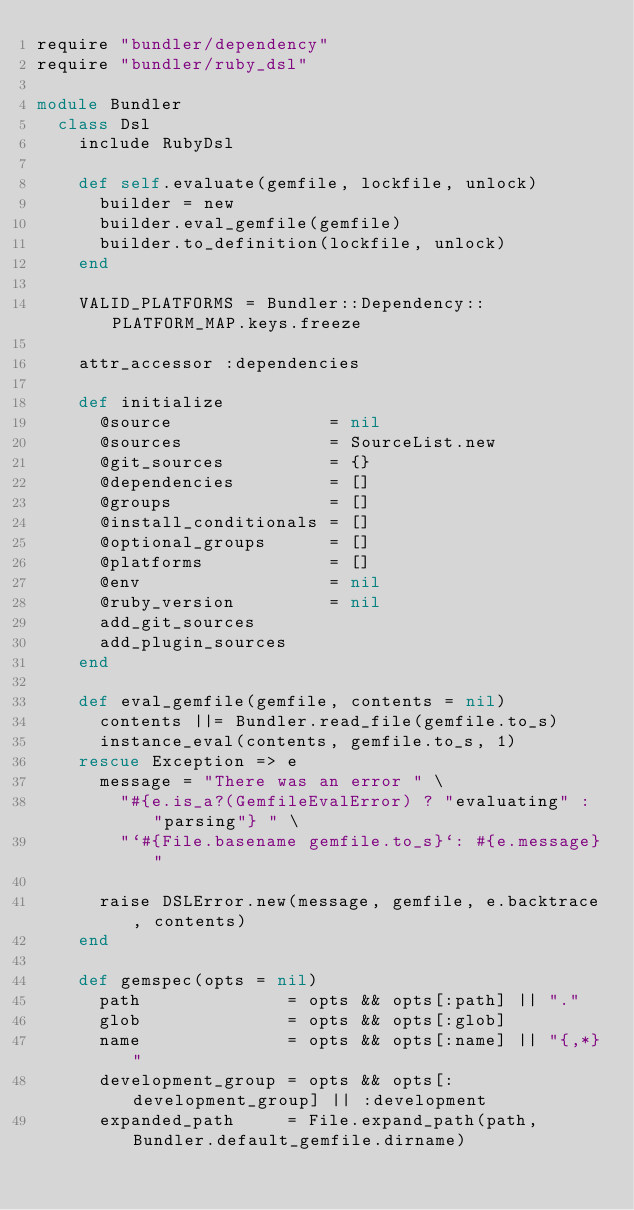<code> <loc_0><loc_0><loc_500><loc_500><_Ruby_>require "bundler/dependency"
require "bundler/ruby_dsl"

module Bundler
  class Dsl
    include RubyDsl

    def self.evaluate(gemfile, lockfile, unlock)
      builder = new
      builder.eval_gemfile(gemfile)
      builder.to_definition(lockfile, unlock)
    end

    VALID_PLATFORMS = Bundler::Dependency::PLATFORM_MAP.keys.freeze

    attr_accessor :dependencies

    def initialize
      @source               = nil
      @sources              = SourceList.new
      @git_sources          = {}
      @dependencies         = []
      @groups               = []
      @install_conditionals = []
      @optional_groups      = []
      @platforms            = []
      @env                  = nil
      @ruby_version         = nil
      add_git_sources
      add_plugin_sources
    end

    def eval_gemfile(gemfile, contents = nil)
      contents ||= Bundler.read_file(gemfile.to_s)
      instance_eval(contents, gemfile.to_s, 1)
    rescue Exception => e
      message = "There was an error " \
        "#{e.is_a?(GemfileEvalError) ? "evaluating" : "parsing"} " \
        "`#{File.basename gemfile.to_s}`: #{e.message}"

      raise DSLError.new(message, gemfile, e.backtrace, contents)
    end

    def gemspec(opts = nil)
      path              = opts && opts[:path] || "."
      glob              = opts && opts[:glob]
      name              = opts && opts[:name] || "{,*}"
      development_group = opts && opts[:development_group] || :development
      expanded_path     = File.expand_path(path, Bundler.default_gemfile.dirname)
</code> 